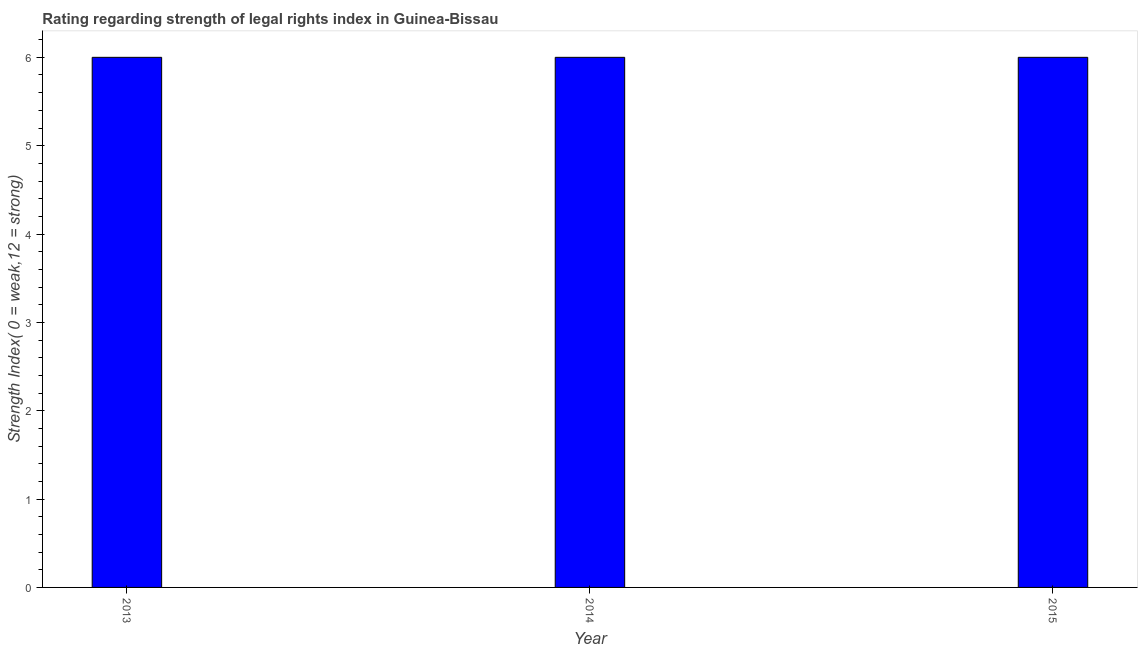Does the graph contain grids?
Keep it short and to the point. No. What is the title of the graph?
Your response must be concise. Rating regarding strength of legal rights index in Guinea-Bissau. What is the label or title of the X-axis?
Keep it short and to the point. Year. What is the label or title of the Y-axis?
Make the answer very short. Strength Index( 0 = weak,12 = strong). Across all years, what is the minimum strength of legal rights index?
Your answer should be compact. 6. In which year was the strength of legal rights index minimum?
Your answer should be very brief. 2013. What is the sum of the strength of legal rights index?
Keep it short and to the point. 18. What is the difference between the strength of legal rights index in 2014 and 2015?
Make the answer very short. 0. What is the average strength of legal rights index per year?
Provide a succinct answer. 6. What is the median strength of legal rights index?
Your response must be concise. 6. What is the ratio of the strength of legal rights index in 2013 to that in 2015?
Your response must be concise. 1. Is the strength of legal rights index in 2013 less than that in 2015?
Your response must be concise. No. Is the difference between the strength of legal rights index in 2013 and 2014 greater than the difference between any two years?
Offer a very short reply. Yes. Is the sum of the strength of legal rights index in 2014 and 2015 greater than the maximum strength of legal rights index across all years?
Keep it short and to the point. Yes. What is the difference between the highest and the lowest strength of legal rights index?
Keep it short and to the point. 0. In how many years, is the strength of legal rights index greater than the average strength of legal rights index taken over all years?
Offer a very short reply. 0. What is the Strength Index( 0 = weak,12 = strong) in 2013?
Offer a terse response. 6. What is the difference between the Strength Index( 0 = weak,12 = strong) in 2013 and 2014?
Your answer should be very brief. 0. What is the difference between the Strength Index( 0 = weak,12 = strong) in 2013 and 2015?
Provide a short and direct response. 0. What is the difference between the Strength Index( 0 = weak,12 = strong) in 2014 and 2015?
Provide a short and direct response. 0. 